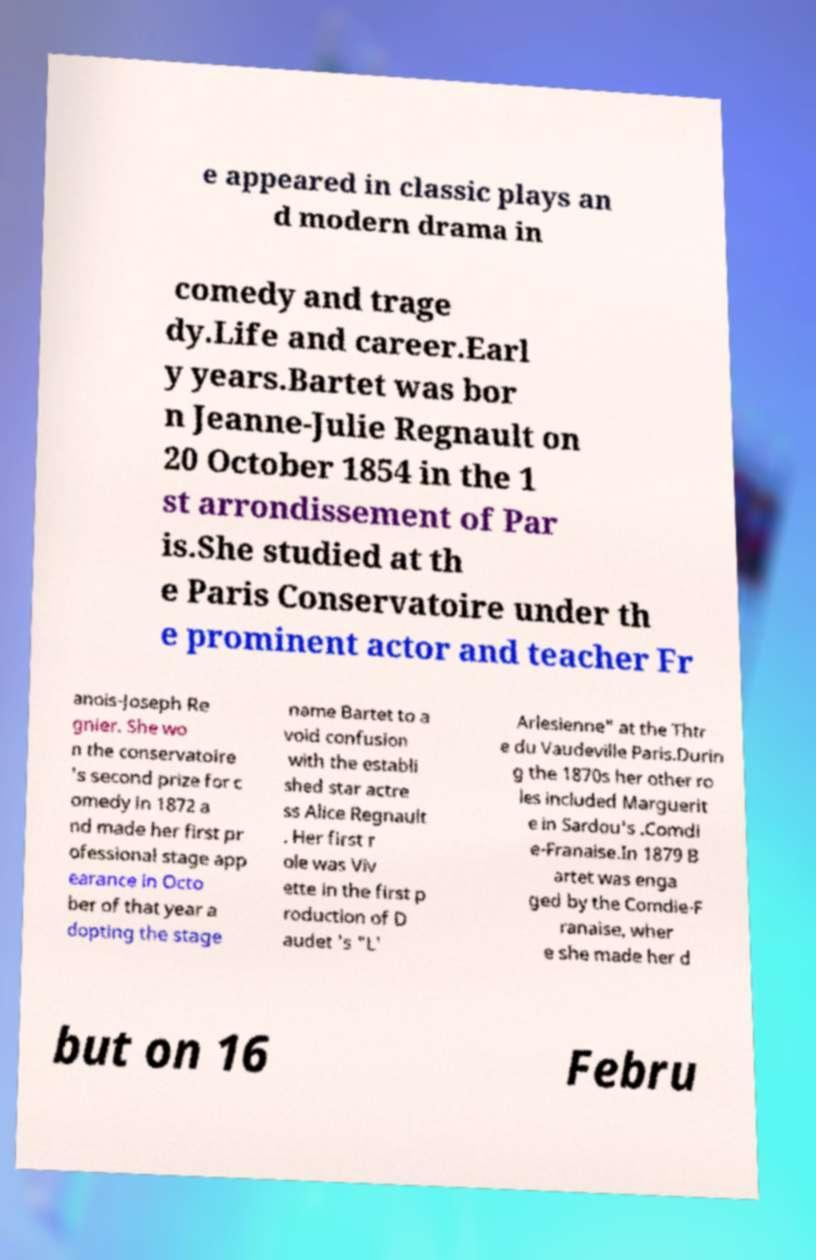I need the written content from this picture converted into text. Can you do that? e appeared in classic plays an d modern drama in comedy and trage dy.Life and career.Earl y years.Bartet was bor n Jeanne-Julie Regnault on 20 October 1854 in the 1 st arrondissement of Par is.She studied at th e Paris Conservatoire under th e prominent actor and teacher Fr anois-Joseph Re gnier. She wo n the conservatoire 's second prize for c omedy in 1872 a nd made her first pr ofessional stage app earance in Octo ber of that year a dopting the stage name Bartet to a void confusion with the establi shed star actre ss Alice Regnault . Her first r ole was Viv ette in the first p roduction of D audet 's "L' Arlesienne" at the Thtr e du Vaudeville Paris.Durin g the 1870s her other ro les included Marguerit e in Sardou's .Comdi e-Franaise.In 1879 B artet was enga ged by the Comdie-F ranaise, wher e she made her d but on 16 Febru 